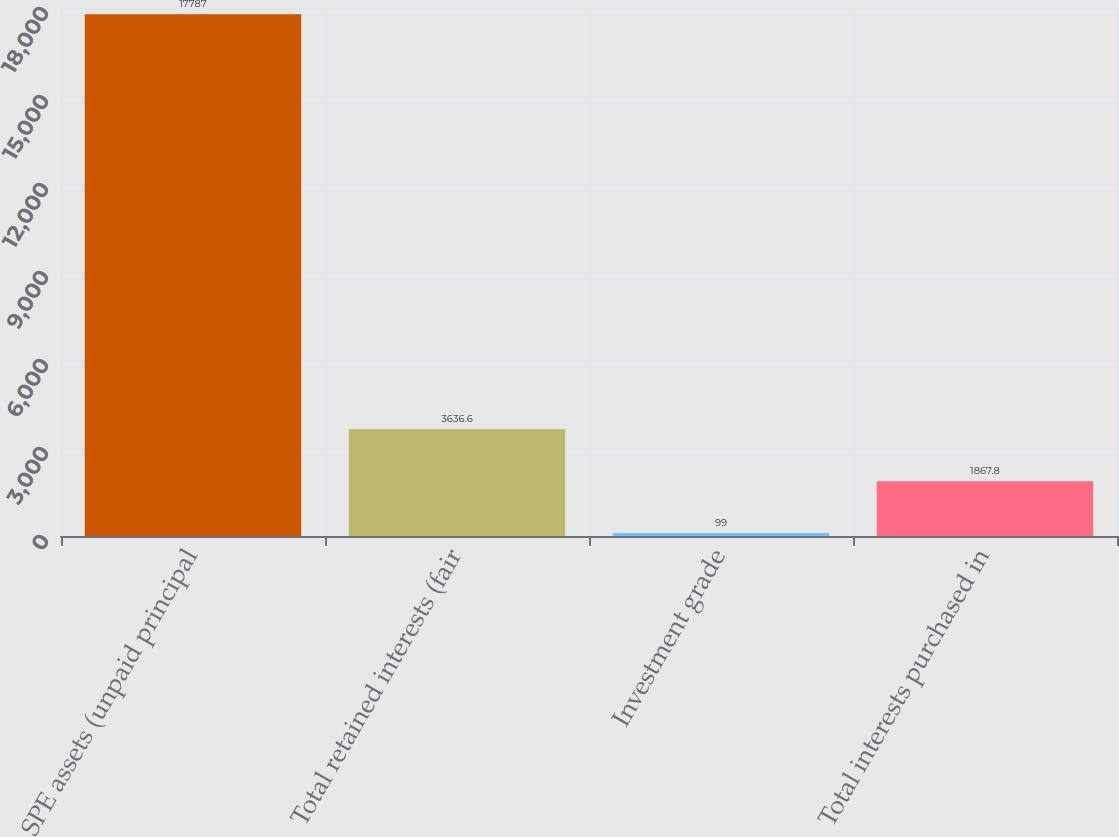Convert chart to OTSL. <chart><loc_0><loc_0><loc_500><loc_500><bar_chart><fcel>SPE assets (unpaid principal<fcel>Total retained interests (fair<fcel>Investment grade<fcel>Total interests purchased in<nl><fcel>17787<fcel>3636.6<fcel>99<fcel>1867.8<nl></chart> 